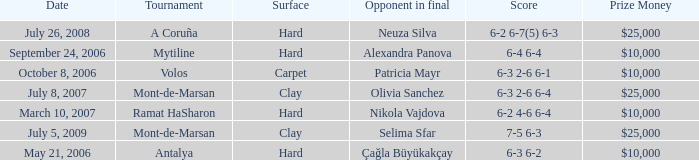Help me parse the entirety of this table. {'header': ['Date', 'Tournament', 'Surface', 'Opponent in final', 'Score', 'Prize Money'], 'rows': [['July 26, 2008', 'A Coruña', 'Hard', 'Neuza Silva', '6-2 6-7(5) 6-3', '$25,000'], ['September 24, 2006', 'Mytiline', 'Hard', 'Alexandra Panova', '6-4 6-4', '$10,000'], ['October 8, 2006', 'Volos', 'Carpet', 'Patricia Mayr', '6-3 2-6 6-1', '$10,000'], ['July 8, 2007', 'Mont-de-Marsan', 'Clay', 'Olivia Sanchez', '6-3 2-6 6-4', '$25,000'], ['March 10, 2007', 'Ramat HaSharon', 'Hard', 'Nikola Vajdova', '6-2 4-6 6-4', '$10,000'], ['July 5, 2009', 'Mont-de-Marsan', 'Clay', 'Selima Sfar', '7-5 6-3', '$25,000'], ['May 21, 2006', 'Antalya', 'Hard', 'Çağla Büyükakçay', '6-3 6-2', '$10,000']]} What is the surface of the match on July 5, 2009? Clay. 